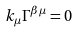<formula> <loc_0><loc_0><loc_500><loc_500>k _ { \mu } \Gamma ^ { \beta \mu } = 0</formula> 